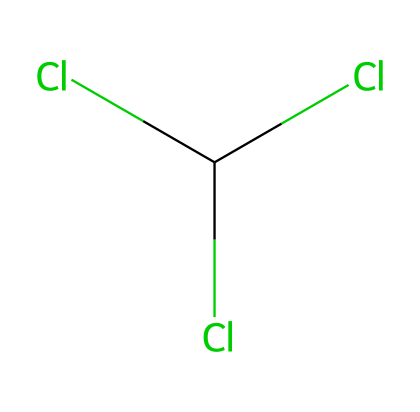What is the molecular formula of this chemical? The SMILES representation indicates chlorine (Cl) and carbon (C) atoms. Counting them results in one carbon atom and three chlorine atoms, forming the molecular formula CCl3.
Answer: CCl3 How many chlorine atoms are present in this molecule? By analyzing the SMILES, we can see that there are three instances of "Cl" indicating three chlorine atoms within the molecular structure.
Answer: 3 What is the bonding pattern among the atoms in this chemical? The structure suggests that the central carbon atom is bonded to three chlorine atoms via single bonds, creating a tetrahedral format typical of chlorinated compounds.
Answer: three single bonds What type of compound is chloroform classified as? Chloroform, represented in the SMILES, contains carbon and chlorine, categorizing it as a halogenated hydrocarbon or specifically a chlorinated solvent.
Answer: halogenated hydrocarbon How does the presence of chlorine affect the chemical's stability? Chlorine atoms increase the electronegativity, making the compound relatively stable yet can lead to reactivity in the presence of certain strong bases or light, affecting its stability compared to hydrocarbons.
Answer: relatively stable In which century was chloroform widely used as an anesthetic? Historical records indicate that chloroform began being widely used as an anesthetic in the 19th century, marking significant advances in surgical practices.
Answer: 19th century 